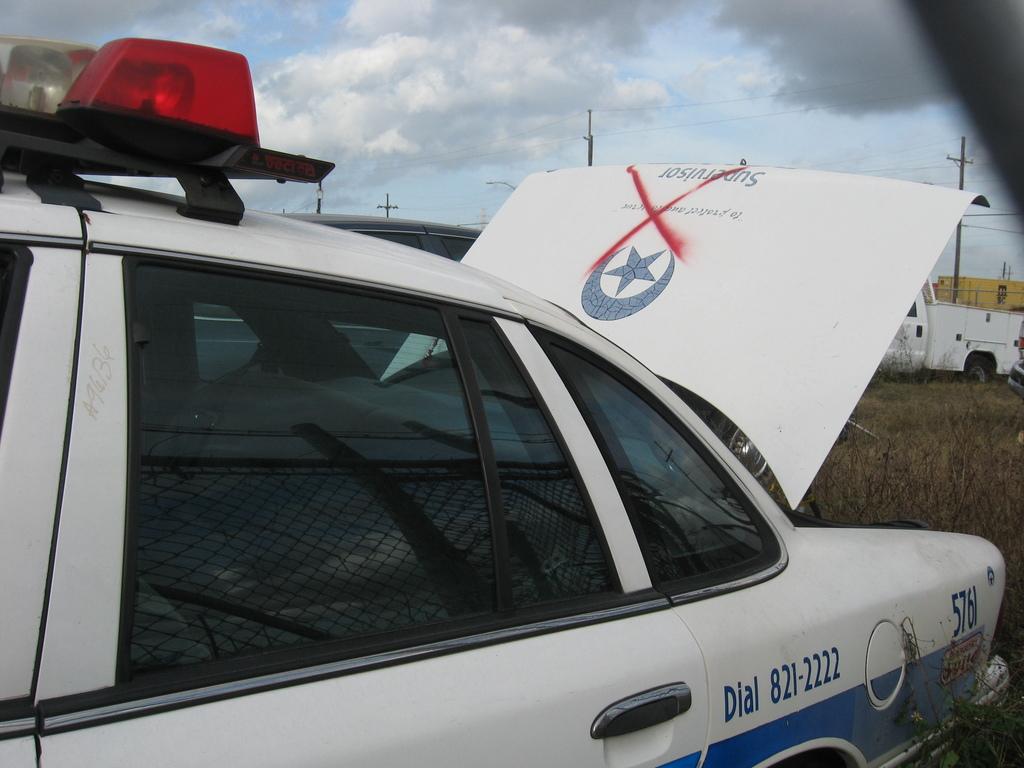What does the car tell you to dial?
Make the answer very short. 821-2222. What number is the car?
Give a very brief answer. 5761. 